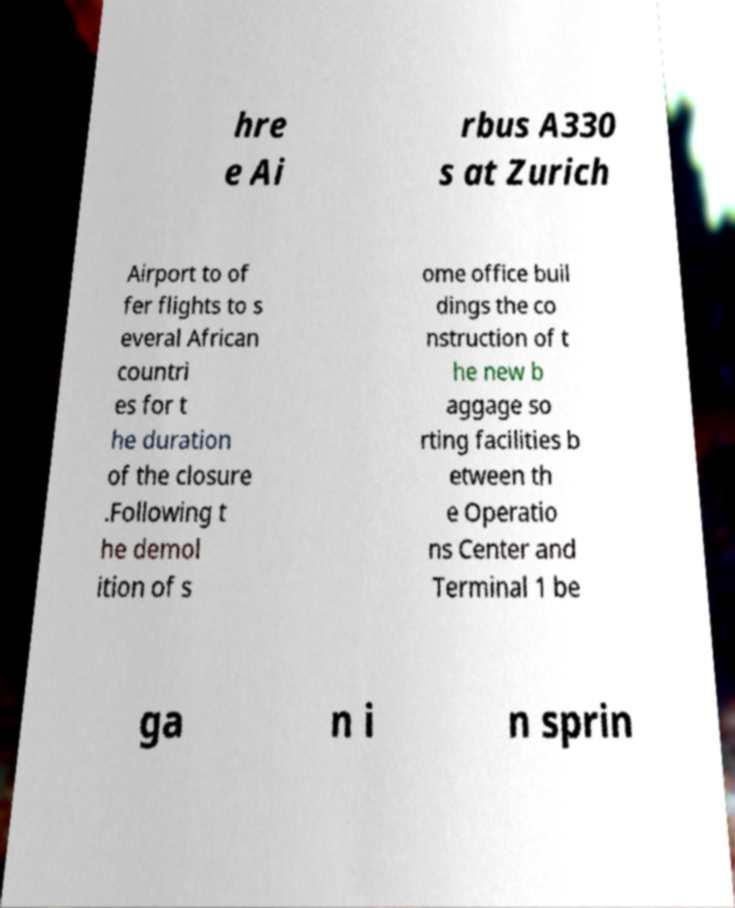Could you assist in decoding the text presented in this image and type it out clearly? hre e Ai rbus A330 s at Zurich Airport to of fer flights to s everal African countri es for t he duration of the closure .Following t he demol ition of s ome office buil dings the co nstruction of t he new b aggage so rting facilities b etween th e Operatio ns Center and Terminal 1 be ga n i n sprin 